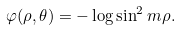<formula> <loc_0><loc_0><loc_500><loc_500>\varphi ( \rho , \theta ) = - \log \sin ^ { 2 } m \rho .</formula> 